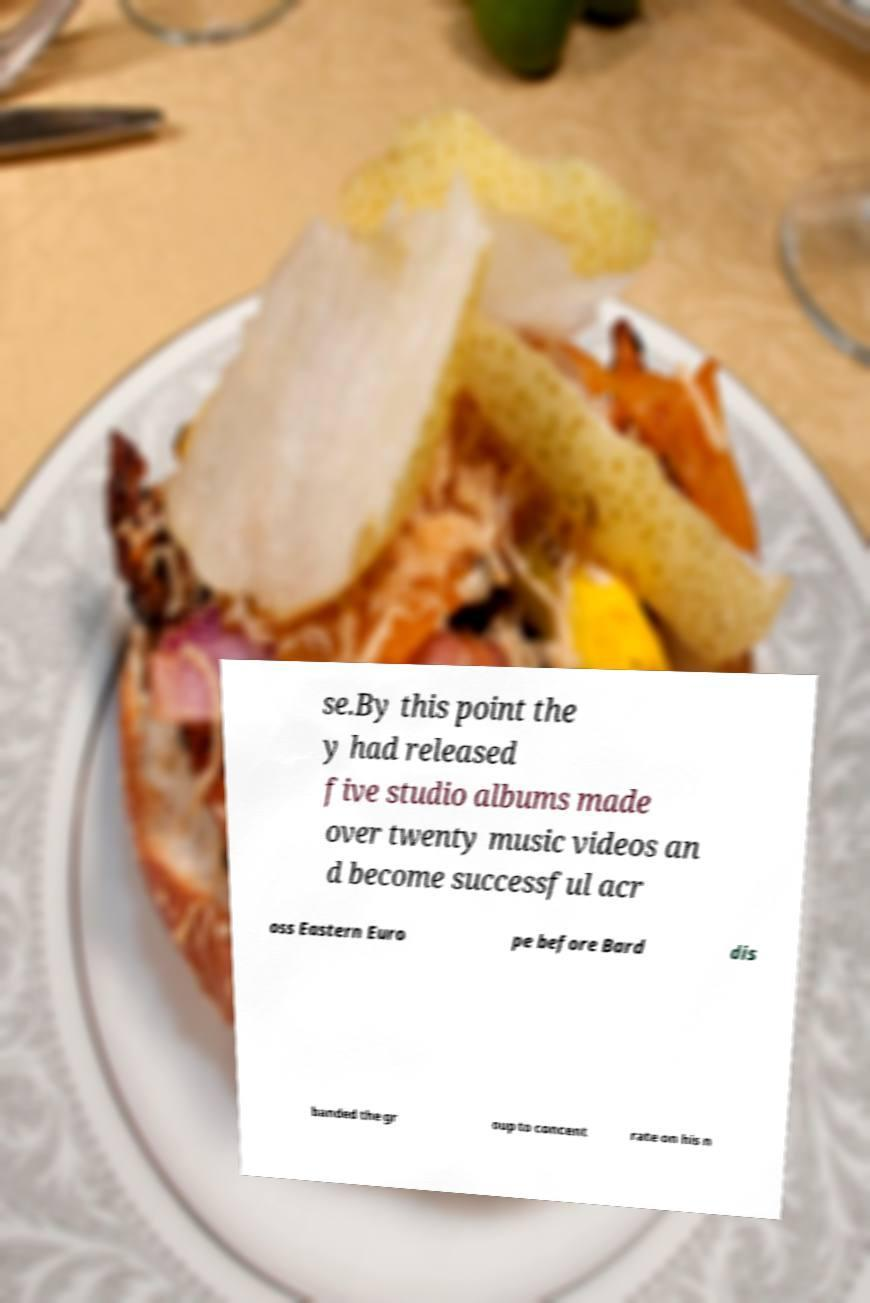I need the written content from this picture converted into text. Can you do that? se.By this point the y had released five studio albums made over twenty music videos an d become successful acr oss Eastern Euro pe before Bard dis banded the gr oup to concent rate on his n 